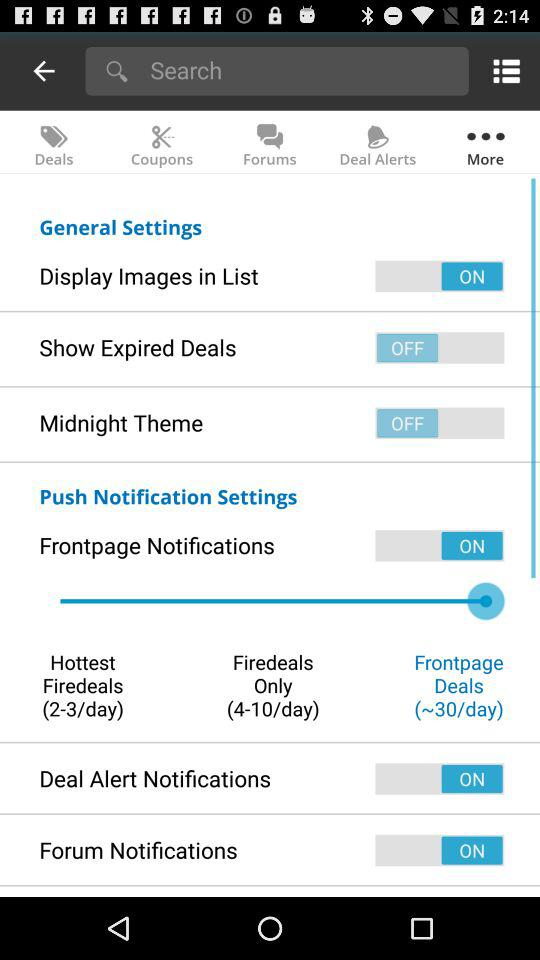How many "Frontpage Deals" are there per day? There are 30 "Frontpage Deals" per day. 